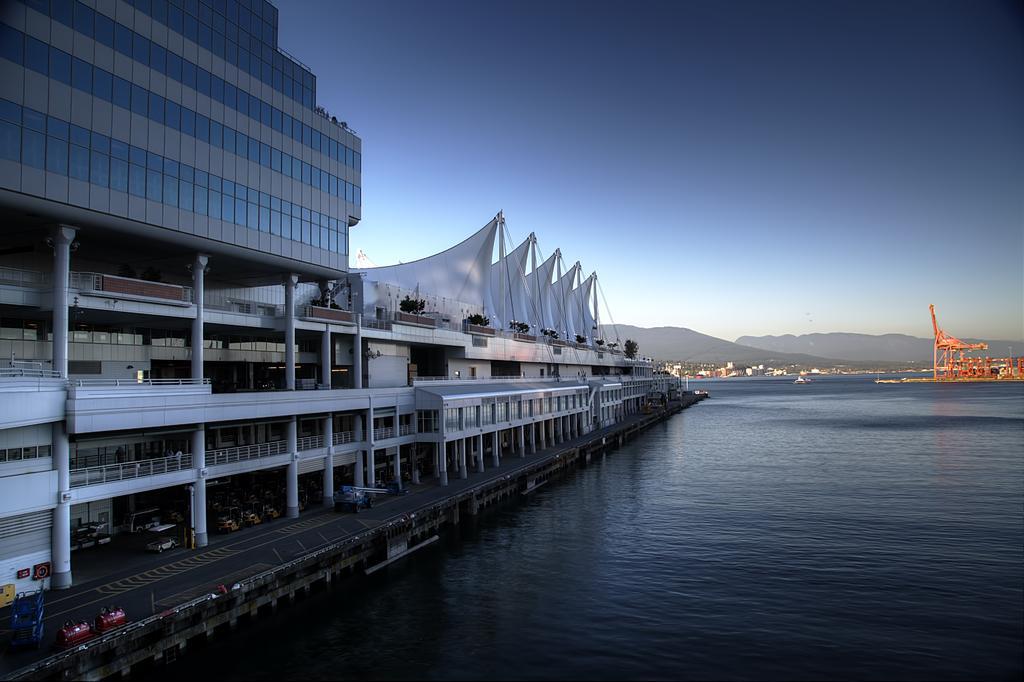Can you describe this image briefly? As we can see in the image there are buildings, water and in the background there are trees. At the top there is sky. 